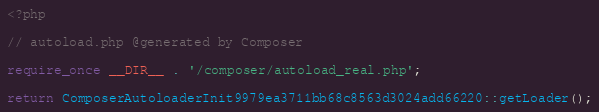<code> <loc_0><loc_0><loc_500><loc_500><_PHP_><?php

// autoload.php @generated by Composer

require_once __DIR__ . '/composer/autoload_real.php';

return ComposerAutoloaderInit9979ea3711bb68c8563d3024add66220::getLoader();
</code> 